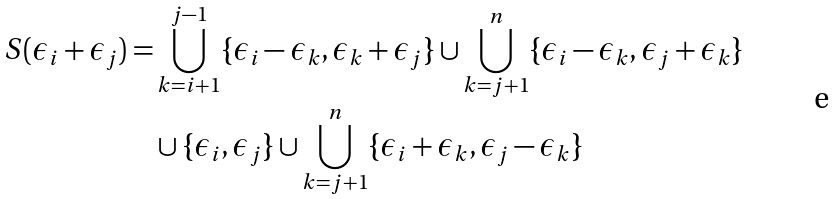<formula> <loc_0><loc_0><loc_500><loc_500>S ( \epsilon _ { i } + \epsilon _ { j } ) = & \bigcup _ { k = i + 1 } ^ { j - 1 } \{ \epsilon _ { i } - \epsilon _ { k } , \epsilon _ { k } + \epsilon _ { j } \} \cup \bigcup _ { k = j + 1 } ^ { n } \{ \epsilon _ { i } - \epsilon _ { k } , \epsilon _ { j } + \epsilon _ { k } \} \\ & \cup \{ \epsilon _ { i } , \epsilon _ { j } \} \cup \bigcup _ { k = j + 1 } ^ { n } \{ \epsilon _ { i } + \epsilon _ { k } , \epsilon _ { j } - \epsilon _ { k } \}</formula> 